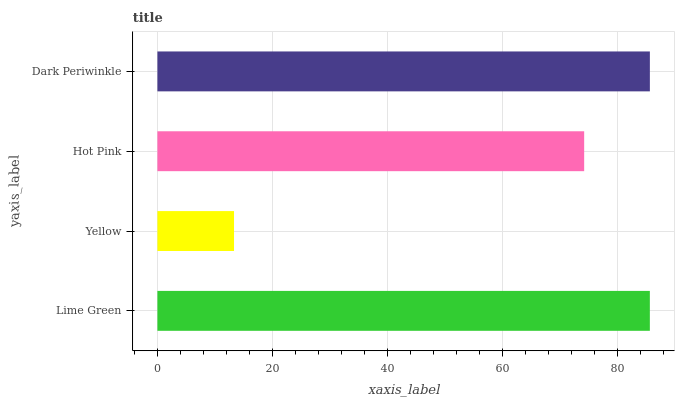Is Yellow the minimum?
Answer yes or no. Yes. Is Dark Periwinkle the maximum?
Answer yes or no. Yes. Is Hot Pink the minimum?
Answer yes or no. No. Is Hot Pink the maximum?
Answer yes or no. No. Is Hot Pink greater than Yellow?
Answer yes or no. Yes. Is Yellow less than Hot Pink?
Answer yes or no. Yes. Is Yellow greater than Hot Pink?
Answer yes or no. No. Is Hot Pink less than Yellow?
Answer yes or no. No. Is Lime Green the high median?
Answer yes or no. Yes. Is Hot Pink the low median?
Answer yes or no. Yes. Is Dark Periwinkle the high median?
Answer yes or no. No. Is Yellow the low median?
Answer yes or no. No. 